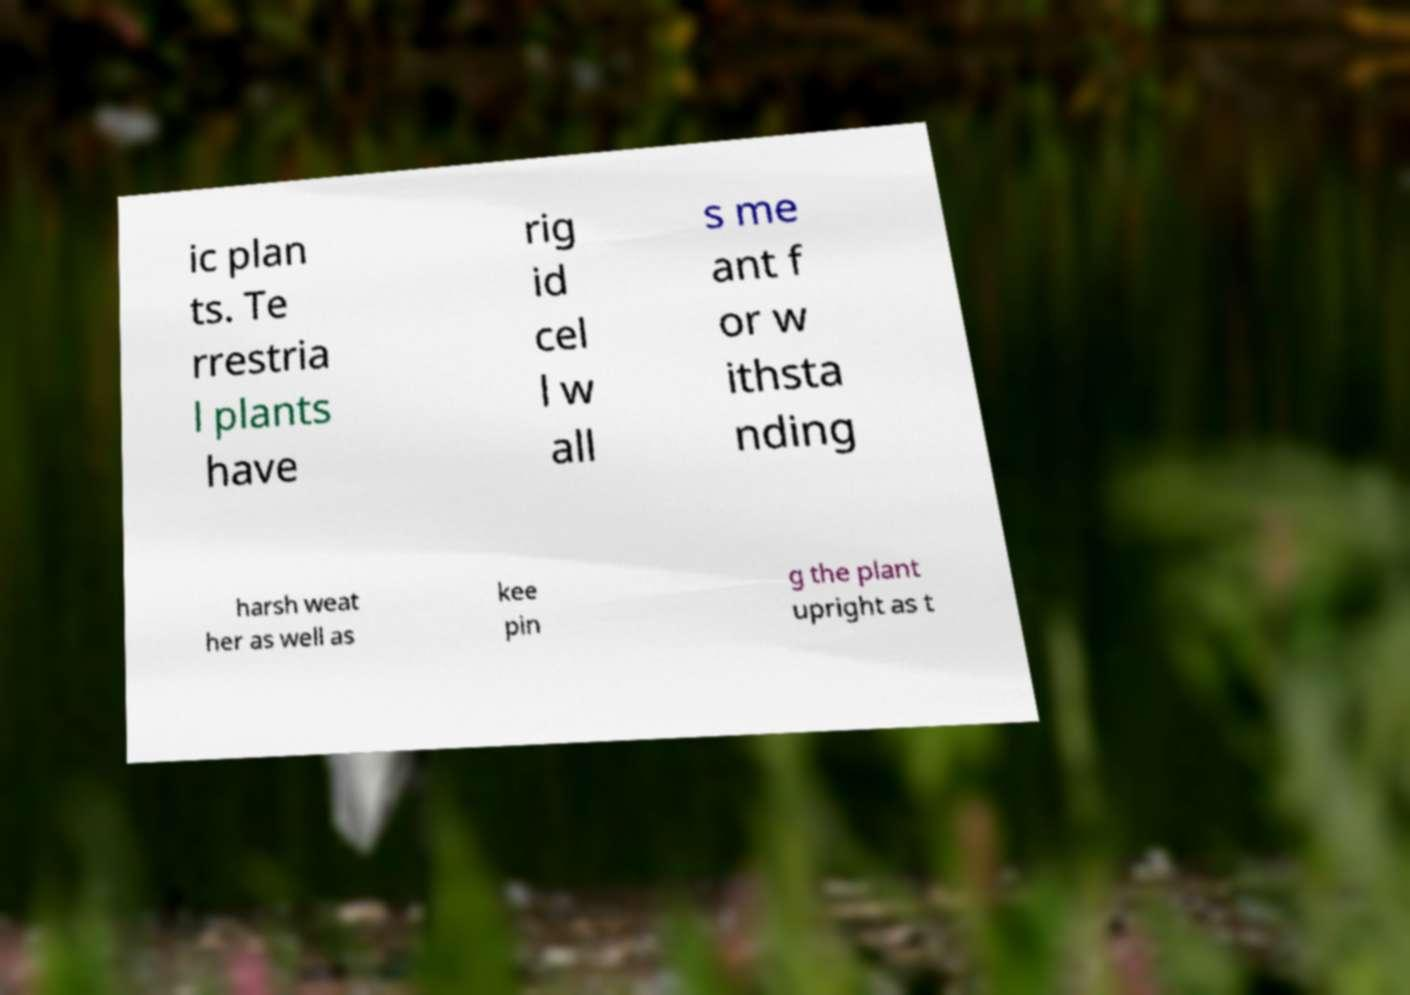Could you extract and type out the text from this image? ic plan ts. Te rrestria l plants have rig id cel l w all s me ant f or w ithsta nding harsh weat her as well as kee pin g the plant upright as t 